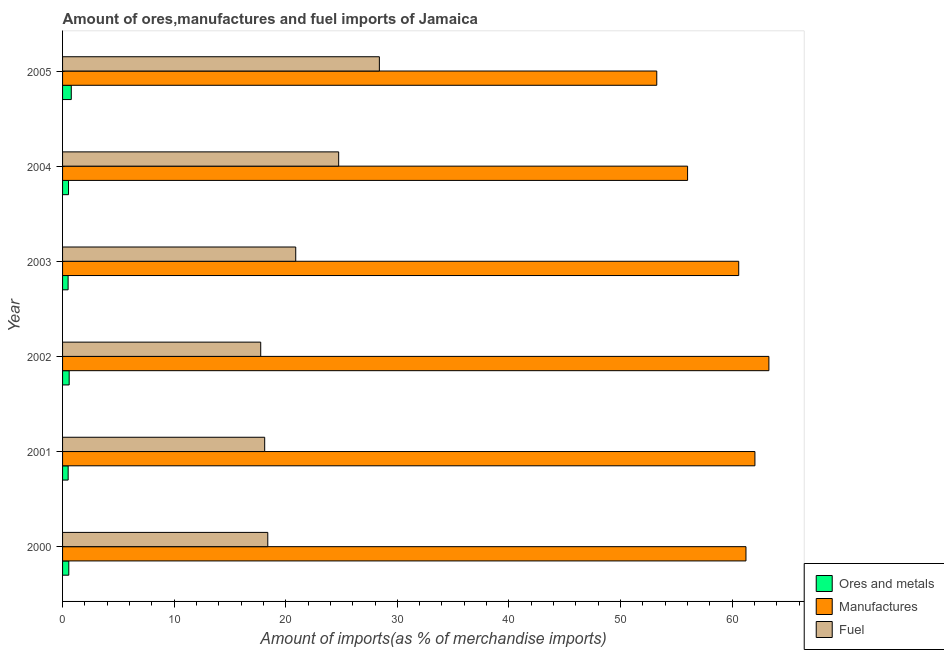How many different coloured bars are there?
Offer a terse response. 3. Are the number of bars on each tick of the Y-axis equal?
Your response must be concise. Yes. How many bars are there on the 1st tick from the bottom?
Ensure brevity in your answer.  3. What is the label of the 5th group of bars from the top?
Your answer should be very brief. 2001. What is the percentage of ores and metals imports in 2002?
Your answer should be compact. 0.59. Across all years, what is the maximum percentage of ores and metals imports?
Your answer should be very brief. 0.78. Across all years, what is the minimum percentage of fuel imports?
Offer a terse response. 17.76. What is the total percentage of manufactures imports in the graph?
Your answer should be very brief. 356.46. What is the difference between the percentage of ores and metals imports in 2001 and that in 2004?
Make the answer very short. -0.03. What is the difference between the percentage of manufactures imports in 2000 and the percentage of ores and metals imports in 2003?
Give a very brief answer. 60.75. What is the average percentage of manufactures imports per year?
Ensure brevity in your answer.  59.41. In the year 2001, what is the difference between the percentage of fuel imports and percentage of manufactures imports?
Provide a succinct answer. -43.93. In how many years, is the percentage of fuel imports greater than 18 %?
Your response must be concise. 5. What is the ratio of the percentage of fuel imports in 2004 to that in 2005?
Your answer should be compact. 0.87. Is the difference between the percentage of ores and metals imports in 2000 and 2003 greater than the difference between the percentage of manufactures imports in 2000 and 2003?
Your answer should be very brief. No. What is the difference between the highest and the second highest percentage of manufactures imports?
Offer a very short reply. 1.25. What is the difference between the highest and the lowest percentage of fuel imports?
Offer a terse response. 10.63. In how many years, is the percentage of ores and metals imports greater than the average percentage of ores and metals imports taken over all years?
Your response must be concise. 2. Is the sum of the percentage of manufactures imports in 2000 and 2001 greater than the maximum percentage of fuel imports across all years?
Make the answer very short. Yes. What does the 2nd bar from the top in 2002 represents?
Provide a short and direct response. Manufactures. What does the 3rd bar from the bottom in 2003 represents?
Give a very brief answer. Fuel. Is it the case that in every year, the sum of the percentage of ores and metals imports and percentage of manufactures imports is greater than the percentage of fuel imports?
Your answer should be compact. Yes. How many bars are there?
Make the answer very short. 18. What is the difference between two consecutive major ticks on the X-axis?
Provide a short and direct response. 10. Are the values on the major ticks of X-axis written in scientific E-notation?
Offer a very short reply. No. Where does the legend appear in the graph?
Provide a succinct answer. Bottom right. How are the legend labels stacked?
Your answer should be compact. Vertical. What is the title of the graph?
Provide a succinct answer. Amount of ores,manufactures and fuel imports of Jamaica. What is the label or title of the X-axis?
Provide a short and direct response. Amount of imports(as % of merchandise imports). What is the label or title of the Y-axis?
Make the answer very short. Year. What is the Amount of imports(as % of merchandise imports) of Ores and metals in 2000?
Ensure brevity in your answer.  0.56. What is the Amount of imports(as % of merchandise imports) in Manufactures in 2000?
Give a very brief answer. 61.25. What is the Amount of imports(as % of merchandise imports) of Fuel in 2000?
Offer a terse response. 18.39. What is the Amount of imports(as % of merchandise imports) of Ores and metals in 2001?
Provide a succinct answer. 0.5. What is the Amount of imports(as % of merchandise imports) in Manufactures in 2001?
Ensure brevity in your answer.  62.05. What is the Amount of imports(as % of merchandise imports) of Fuel in 2001?
Offer a very short reply. 18.11. What is the Amount of imports(as % of merchandise imports) of Ores and metals in 2002?
Your response must be concise. 0.59. What is the Amount of imports(as % of merchandise imports) of Manufactures in 2002?
Offer a terse response. 63.3. What is the Amount of imports(as % of merchandise imports) in Fuel in 2002?
Offer a very short reply. 17.76. What is the Amount of imports(as % of merchandise imports) of Ores and metals in 2003?
Your answer should be compact. 0.5. What is the Amount of imports(as % of merchandise imports) in Manufactures in 2003?
Your response must be concise. 60.6. What is the Amount of imports(as % of merchandise imports) of Fuel in 2003?
Give a very brief answer. 20.9. What is the Amount of imports(as % of merchandise imports) in Ores and metals in 2004?
Your answer should be compact. 0.53. What is the Amount of imports(as % of merchandise imports) in Manufactures in 2004?
Ensure brevity in your answer.  56.01. What is the Amount of imports(as % of merchandise imports) in Fuel in 2004?
Provide a succinct answer. 24.74. What is the Amount of imports(as % of merchandise imports) in Ores and metals in 2005?
Your answer should be compact. 0.78. What is the Amount of imports(as % of merchandise imports) in Manufactures in 2005?
Provide a short and direct response. 53.25. What is the Amount of imports(as % of merchandise imports) in Fuel in 2005?
Your answer should be compact. 28.39. Across all years, what is the maximum Amount of imports(as % of merchandise imports) of Ores and metals?
Your answer should be compact. 0.78. Across all years, what is the maximum Amount of imports(as % of merchandise imports) of Manufactures?
Your response must be concise. 63.3. Across all years, what is the maximum Amount of imports(as % of merchandise imports) in Fuel?
Offer a terse response. 28.39. Across all years, what is the minimum Amount of imports(as % of merchandise imports) in Ores and metals?
Your answer should be very brief. 0.5. Across all years, what is the minimum Amount of imports(as % of merchandise imports) of Manufactures?
Offer a very short reply. 53.25. Across all years, what is the minimum Amount of imports(as % of merchandise imports) of Fuel?
Your answer should be compact. 17.76. What is the total Amount of imports(as % of merchandise imports) of Ores and metals in the graph?
Offer a very short reply. 3.46. What is the total Amount of imports(as % of merchandise imports) of Manufactures in the graph?
Keep it short and to the point. 356.46. What is the total Amount of imports(as % of merchandise imports) in Fuel in the graph?
Ensure brevity in your answer.  128.3. What is the difference between the Amount of imports(as % of merchandise imports) of Ores and metals in 2000 and that in 2001?
Your answer should be very brief. 0.06. What is the difference between the Amount of imports(as % of merchandise imports) of Manufactures in 2000 and that in 2001?
Your answer should be compact. -0.8. What is the difference between the Amount of imports(as % of merchandise imports) in Fuel in 2000 and that in 2001?
Your answer should be compact. 0.28. What is the difference between the Amount of imports(as % of merchandise imports) in Ores and metals in 2000 and that in 2002?
Provide a succinct answer. -0.03. What is the difference between the Amount of imports(as % of merchandise imports) of Manufactures in 2000 and that in 2002?
Offer a very short reply. -2.05. What is the difference between the Amount of imports(as % of merchandise imports) of Fuel in 2000 and that in 2002?
Make the answer very short. 0.63. What is the difference between the Amount of imports(as % of merchandise imports) in Ores and metals in 2000 and that in 2003?
Your answer should be very brief. 0.06. What is the difference between the Amount of imports(as % of merchandise imports) in Manufactures in 2000 and that in 2003?
Give a very brief answer. 0.65. What is the difference between the Amount of imports(as % of merchandise imports) in Fuel in 2000 and that in 2003?
Offer a very short reply. -2.51. What is the difference between the Amount of imports(as % of merchandise imports) in Ores and metals in 2000 and that in 2004?
Your answer should be compact. 0.03. What is the difference between the Amount of imports(as % of merchandise imports) of Manufactures in 2000 and that in 2004?
Make the answer very short. 5.23. What is the difference between the Amount of imports(as % of merchandise imports) of Fuel in 2000 and that in 2004?
Your answer should be very brief. -6.35. What is the difference between the Amount of imports(as % of merchandise imports) of Ores and metals in 2000 and that in 2005?
Your response must be concise. -0.22. What is the difference between the Amount of imports(as % of merchandise imports) of Manufactures in 2000 and that in 2005?
Give a very brief answer. 7.99. What is the difference between the Amount of imports(as % of merchandise imports) in Fuel in 2000 and that in 2005?
Provide a short and direct response. -10. What is the difference between the Amount of imports(as % of merchandise imports) of Ores and metals in 2001 and that in 2002?
Ensure brevity in your answer.  -0.09. What is the difference between the Amount of imports(as % of merchandise imports) of Manufactures in 2001 and that in 2002?
Make the answer very short. -1.25. What is the difference between the Amount of imports(as % of merchandise imports) of Fuel in 2001 and that in 2002?
Provide a succinct answer. 0.36. What is the difference between the Amount of imports(as % of merchandise imports) in Ores and metals in 2001 and that in 2003?
Your response must be concise. 0. What is the difference between the Amount of imports(as % of merchandise imports) of Manufactures in 2001 and that in 2003?
Your response must be concise. 1.45. What is the difference between the Amount of imports(as % of merchandise imports) in Fuel in 2001 and that in 2003?
Keep it short and to the point. -2.78. What is the difference between the Amount of imports(as % of merchandise imports) in Ores and metals in 2001 and that in 2004?
Provide a succinct answer. -0.03. What is the difference between the Amount of imports(as % of merchandise imports) in Manufactures in 2001 and that in 2004?
Your response must be concise. 6.03. What is the difference between the Amount of imports(as % of merchandise imports) of Fuel in 2001 and that in 2004?
Give a very brief answer. -6.63. What is the difference between the Amount of imports(as % of merchandise imports) in Ores and metals in 2001 and that in 2005?
Provide a short and direct response. -0.28. What is the difference between the Amount of imports(as % of merchandise imports) in Manufactures in 2001 and that in 2005?
Provide a short and direct response. 8.8. What is the difference between the Amount of imports(as % of merchandise imports) in Fuel in 2001 and that in 2005?
Provide a short and direct response. -10.28. What is the difference between the Amount of imports(as % of merchandise imports) in Ores and metals in 2002 and that in 2003?
Ensure brevity in your answer.  0.1. What is the difference between the Amount of imports(as % of merchandise imports) of Manufactures in 2002 and that in 2003?
Provide a short and direct response. 2.7. What is the difference between the Amount of imports(as % of merchandise imports) of Fuel in 2002 and that in 2003?
Your answer should be compact. -3.14. What is the difference between the Amount of imports(as % of merchandise imports) of Ores and metals in 2002 and that in 2004?
Provide a succinct answer. 0.06. What is the difference between the Amount of imports(as % of merchandise imports) of Manufactures in 2002 and that in 2004?
Offer a terse response. 7.29. What is the difference between the Amount of imports(as % of merchandise imports) of Fuel in 2002 and that in 2004?
Give a very brief answer. -6.99. What is the difference between the Amount of imports(as % of merchandise imports) in Ores and metals in 2002 and that in 2005?
Your answer should be compact. -0.19. What is the difference between the Amount of imports(as % of merchandise imports) in Manufactures in 2002 and that in 2005?
Your answer should be very brief. 10.05. What is the difference between the Amount of imports(as % of merchandise imports) of Fuel in 2002 and that in 2005?
Ensure brevity in your answer.  -10.63. What is the difference between the Amount of imports(as % of merchandise imports) in Ores and metals in 2003 and that in 2004?
Provide a succinct answer. -0.04. What is the difference between the Amount of imports(as % of merchandise imports) in Manufactures in 2003 and that in 2004?
Make the answer very short. 4.58. What is the difference between the Amount of imports(as % of merchandise imports) in Fuel in 2003 and that in 2004?
Keep it short and to the point. -3.85. What is the difference between the Amount of imports(as % of merchandise imports) in Ores and metals in 2003 and that in 2005?
Your answer should be compact. -0.28. What is the difference between the Amount of imports(as % of merchandise imports) in Manufactures in 2003 and that in 2005?
Ensure brevity in your answer.  7.34. What is the difference between the Amount of imports(as % of merchandise imports) of Fuel in 2003 and that in 2005?
Provide a short and direct response. -7.5. What is the difference between the Amount of imports(as % of merchandise imports) of Ores and metals in 2004 and that in 2005?
Offer a terse response. -0.25. What is the difference between the Amount of imports(as % of merchandise imports) of Manufactures in 2004 and that in 2005?
Ensure brevity in your answer.  2.76. What is the difference between the Amount of imports(as % of merchandise imports) in Fuel in 2004 and that in 2005?
Provide a succinct answer. -3.65. What is the difference between the Amount of imports(as % of merchandise imports) of Ores and metals in 2000 and the Amount of imports(as % of merchandise imports) of Manufactures in 2001?
Ensure brevity in your answer.  -61.49. What is the difference between the Amount of imports(as % of merchandise imports) of Ores and metals in 2000 and the Amount of imports(as % of merchandise imports) of Fuel in 2001?
Provide a succinct answer. -17.56. What is the difference between the Amount of imports(as % of merchandise imports) in Manufactures in 2000 and the Amount of imports(as % of merchandise imports) in Fuel in 2001?
Offer a terse response. 43.13. What is the difference between the Amount of imports(as % of merchandise imports) of Ores and metals in 2000 and the Amount of imports(as % of merchandise imports) of Manufactures in 2002?
Keep it short and to the point. -62.74. What is the difference between the Amount of imports(as % of merchandise imports) in Ores and metals in 2000 and the Amount of imports(as % of merchandise imports) in Fuel in 2002?
Your answer should be compact. -17.2. What is the difference between the Amount of imports(as % of merchandise imports) in Manufactures in 2000 and the Amount of imports(as % of merchandise imports) in Fuel in 2002?
Offer a very short reply. 43.49. What is the difference between the Amount of imports(as % of merchandise imports) in Ores and metals in 2000 and the Amount of imports(as % of merchandise imports) in Manufactures in 2003?
Give a very brief answer. -60.04. What is the difference between the Amount of imports(as % of merchandise imports) of Ores and metals in 2000 and the Amount of imports(as % of merchandise imports) of Fuel in 2003?
Provide a succinct answer. -20.34. What is the difference between the Amount of imports(as % of merchandise imports) of Manufactures in 2000 and the Amount of imports(as % of merchandise imports) of Fuel in 2003?
Keep it short and to the point. 40.35. What is the difference between the Amount of imports(as % of merchandise imports) in Ores and metals in 2000 and the Amount of imports(as % of merchandise imports) in Manufactures in 2004?
Provide a succinct answer. -55.46. What is the difference between the Amount of imports(as % of merchandise imports) in Ores and metals in 2000 and the Amount of imports(as % of merchandise imports) in Fuel in 2004?
Provide a short and direct response. -24.19. What is the difference between the Amount of imports(as % of merchandise imports) in Manufactures in 2000 and the Amount of imports(as % of merchandise imports) in Fuel in 2004?
Provide a short and direct response. 36.5. What is the difference between the Amount of imports(as % of merchandise imports) in Ores and metals in 2000 and the Amount of imports(as % of merchandise imports) in Manufactures in 2005?
Ensure brevity in your answer.  -52.69. What is the difference between the Amount of imports(as % of merchandise imports) in Ores and metals in 2000 and the Amount of imports(as % of merchandise imports) in Fuel in 2005?
Make the answer very short. -27.83. What is the difference between the Amount of imports(as % of merchandise imports) in Manufactures in 2000 and the Amount of imports(as % of merchandise imports) in Fuel in 2005?
Your answer should be compact. 32.85. What is the difference between the Amount of imports(as % of merchandise imports) in Ores and metals in 2001 and the Amount of imports(as % of merchandise imports) in Manufactures in 2002?
Your response must be concise. -62.8. What is the difference between the Amount of imports(as % of merchandise imports) of Ores and metals in 2001 and the Amount of imports(as % of merchandise imports) of Fuel in 2002?
Offer a very short reply. -17.26. What is the difference between the Amount of imports(as % of merchandise imports) in Manufactures in 2001 and the Amount of imports(as % of merchandise imports) in Fuel in 2002?
Give a very brief answer. 44.29. What is the difference between the Amount of imports(as % of merchandise imports) of Ores and metals in 2001 and the Amount of imports(as % of merchandise imports) of Manufactures in 2003?
Give a very brief answer. -60.09. What is the difference between the Amount of imports(as % of merchandise imports) in Ores and metals in 2001 and the Amount of imports(as % of merchandise imports) in Fuel in 2003?
Make the answer very short. -20.39. What is the difference between the Amount of imports(as % of merchandise imports) of Manufactures in 2001 and the Amount of imports(as % of merchandise imports) of Fuel in 2003?
Make the answer very short. 41.15. What is the difference between the Amount of imports(as % of merchandise imports) of Ores and metals in 2001 and the Amount of imports(as % of merchandise imports) of Manufactures in 2004?
Ensure brevity in your answer.  -55.51. What is the difference between the Amount of imports(as % of merchandise imports) in Ores and metals in 2001 and the Amount of imports(as % of merchandise imports) in Fuel in 2004?
Make the answer very short. -24.24. What is the difference between the Amount of imports(as % of merchandise imports) of Manufactures in 2001 and the Amount of imports(as % of merchandise imports) of Fuel in 2004?
Offer a very short reply. 37.3. What is the difference between the Amount of imports(as % of merchandise imports) in Ores and metals in 2001 and the Amount of imports(as % of merchandise imports) in Manufactures in 2005?
Ensure brevity in your answer.  -52.75. What is the difference between the Amount of imports(as % of merchandise imports) of Ores and metals in 2001 and the Amount of imports(as % of merchandise imports) of Fuel in 2005?
Your response must be concise. -27.89. What is the difference between the Amount of imports(as % of merchandise imports) of Manufactures in 2001 and the Amount of imports(as % of merchandise imports) of Fuel in 2005?
Make the answer very short. 33.66. What is the difference between the Amount of imports(as % of merchandise imports) of Ores and metals in 2002 and the Amount of imports(as % of merchandise imports) of Manufactures in 2003?
Offer a terse response. -60. What is the difference between the Amount of imports(as % of merchandise imports) in Ores and metals in 2002 and the Amount of imports(as % of merchandise imports) in Fuel in 2003?
Provide a succinct answer. -20.3. What is the difference between the Amount of imports(as % of merchandise imports) in Manufactures in 2002 and the Amount of imports(as % of merchandise imports) in Fuel in 2003?
Give a very brief answer. 42.41. What is the difference between the Amount of imports(as % of merchandise imports) of Ores and metals in 2002 and the Amount of imports(as % of merchandise imports) of Manufactures in 2004?
Offer a terse response. -55.42. What is the difference between the Amount of imports(as % of merchandise imports) in Ores and metals in 2002 and the Amount of imports(as % of merchandise imports) in Fuel in 2004?
Provide a succinct answer. -24.15. What is the difference between the Amount of imports(as % of merchandise imports) of Manufactures in 2002 and the Amount of imports(as % of merchandise imports) of Fuel in 2004?
Offer a terse response. 38.56. What is the difference between the Amount of imports(as % of merchandise imports) of Ores and metals in 2002 and the Amount of imports(as % of merchandise imports) of Manufactures in 2005?
Keep it short and to the point. -52.66. What is the difference between the Amount of imports(as % of merchandise imports) in Ores and metals in 2002 and the Amount of imports(as % of merchandise imports) in Fuel in 2005?
Make the answer very short. -27.8. What is the difference between the Amount of imports(as % of merchandise imports) of Manufactures in 2002 and the Amount of imports(as % of merchandise imports) of Fuel in 2005?
Provide a short and direct response. 34.91. What is the difference between the Amount of imports(as % of merchandise imports) of Ores and metals in 2003 and the Amount of imports(as % of merchandise imports) of Manufactures in 2004?
Your answer should be compact. -55.52. What is the difference between the Amount of imports(as % of merchandise imports) of Ores and metals in 2003 and the Amount of imports(as % of merchandise imports) of Fuel in 2004?
Ensure brevity in your answer.  -24.25. What is the difference between the Amount of imports(as % of merchandise imports) in Manufactures in 2003 and the Amount of imports(as % of merchandise imports) in Fuel in 2004?
Provide a succinct answer. 35.85. What is the difference between the Amount of imports(as % of merchandise imports) of Ores and metals in 2003 and the Amount of imports(as % of merchandise imports) of Manufactures in 2005?
Provide a succinct answer. -52.76. What is the difference between the Amount of imports(as % of merchandise imports) in Ores and metals in 2003 and the Amount of imports(as % of merchandise imports) in Fuel in 2005?
Your answer should be very brief. -27.9. What is the difference between the Amount of imports(as % of merchandise imports) of Manufactures in 2003 and the Amount of imports(as % of merchandise imports) of Fuel in 2005?
Provide a succinct answer. 32.2. What is the difference between the Amount of imports(as % of merchandise imports) in Ores and metals in 2004 and the Amount of imports(as % of merchandise imports) in Manufactures in 2005?
Make the answer very short. -52.72. What is the difference between the Amount of imports(as % of merchandise imports) of Ores and metals in 2004 and the Amount of imports(as % of merchandise imports) of Fuel in 2005?
Provide a succinct answer. -27.86. What is the difference between the Amount of imports(as % of merchandise imports) of Manufactures in 2004 and the Amount of imports(as % of merchandise imports) of Fuel in 2005?
Your answer should be compact. 27.62. What is the average Amount of imports(as % of merchandise imports) in Ores and metals per year?
Provide a succinct answer. 0.58. What is the average Amount of imports(as % of merchandise imports) in Manufactures per year?
Your answer should be very brief. 59.41. What is the average Amount of imports(as % of merchandise imports) of Fuel per year?
Your response must be concise. 21.38. In the year 2000, what is the difference between the Amount of imports(as % of merchandise imports) in Ores and metals and Amount of imports(as % of merchandise imports) in Manufactures?
Give a very brief answer. -60.69. In the year 2000, what is the difference between the Amount of imports(as % of merchandise imports) of Ores and metals and Amount of imports(as % of merchandise imports) of Fuel?
Offer a terse response. -17.83. In the year 2000, what is the difference between the Amount of imports(as % of merchandise imports) of Manufactures and Amount of imports(as % of merchandise imports) of Fuel?
Your answer should be very brief. 42.86. In the year 2001, what is the difference between the Amount of imports(as % of merchandise imports) in Ores and metals and Amount of imports(as % of merchandise imports) in Manufactures?
Ensure brevity in your answer.  -61.55. In the year 2001, what is the difference between the Amount of imports(as % of merchandise imports) in Ores and metals and Amount of imports(as % of merchandise imports) in Fuel?
Your answer should be very brief. -17.61. In the year 2001, what is the difference between the Amount of imports(as % of merchandise imports) in Manufactures and Amount of imports(as % of merchandise imports) in Fuel?
Offer a terse response. 43.93. In the year 2002, what is the difference between the Amount of imports(as % of merchandise imports) of Ores and metals and Amount of imports(as % of merchandise imports) of Manufactures?
Offer a terse response. -62.71. In the year 2002, what is the difference between the Amount of imports(as % of merchandise imports) in Ores and metals and Amount of imports(as % of merchandise imports) in Fuel?
Your answer should be compact. -17.17. In the year 2002, what is the difference between the Amount of imports(as % of merchandise imports) of Manufactures and Amount of imports(as % of merchandise imports) of Fuel?
Provide a short and direct response. 45.54. In the year 2003, what is the difference between the Amount of imports(as % of merchandise imports) of Ores and metals and Amount of imports(as % of merchandise imports) of Manufactures?
Ensure brevity in your answer.  -60.1. In the year 2003, what is the difference between the Amount of imports(as % of merchandise imports) in Ores and metals and Amount of imports(as % of merchandise imports) in Fuel?
Give a very brief answer. -20.4. In the year 2003, what is the difference between the Amount of imports(as % of merchandise imports) in Manufactures and Amount of imports(as % of merchandise imports) in Fuel?
Provide a succinct answer. 39.7. In the year 2004, what is the difference between the Amount of imports(as % of merchandise imports) of Ores and metals and Amount of imports(as % of merchandise imports) of Manufactures?
Your response must be concise. -55.48. In the year 2004, what is the difference between the Amount of imports(as % of merchandise imports) of Ores and metals and Amount of imports(as % of merchandise imports) of Fuel?
Your response must be concise. -24.21. In the year 2004, what is the difference between the Amount of imports(as % of merchandise imports) in Manufactures and Amount of imports(as % of merchandise imports) in Fuel?
Offer a terse response. 31.27. In the year 2005, what is the difference between the Amount of imports(as % of merchandise imports) of Ores and metals and Amount of imports(as % of merchandise imports) of Manufactures?
Keep it short and to the point. -52.47. In the year 2005, what is the difference between the Amount of imports(as % of merchandise imports) of Ores and metals and Amount of imports(as % of merchandise imports) of Fuel?
Ensure brevity in your answer.  -27.61. In the year 2005, what is the difference between the Amount of imports(as % of merchandise imports) of Manufactures and Amount of imports(as % of merchandise imports) of Fuel?
Your response must be concise. 24.86. What is the ratio of the Amount of imports(as % of merchandise imports) in Ores and metals in 2000 to that in 2001?
Provide a succinct answer. 1.11. What is the ratio of the Amount of imports(as % of merchandise imports) of Manufactures in 2000 to that in 2001?
Make the answer very short. 0.99. What is the ratio of the Amount of imports(as % of merchandise imports) of Fuel in 2000 to that in 2001?
Your answer should be very brief. 1.02. What is the ratio of the Amount of imports(as % of merchandise imports) of Ores and metals in 2000 to that in 2002?
Keep it short and to the point. 0.94. What is the ratio of the Amount of imports(as % of merchandise imports) of Manufactures in 2000 to that in 2002?
Offer a terse response. 0.97. What is the ratio of the Amount of imports(as % of merchandise imports) in Fuel in 2000 to that in 2002?
Your answer should be compact. 1.04. What is the ratio of the Amount of imports(as % of merchandise imports) in Ores and metals in 2000 to that in 2003?
Keep it short and to the point. 1.12. What is the ratio of the Amount of imports(as % of merchandise imports) in Manufactures in 2000 to that in 2003?
Your answer should be very brief. 1.01. What is the ratio of the Amount of imports(as % of merchandise imports) in Fuel in 2000 to that in 2003?
Your response must be concise. 0.88. What is the ratio of the Amount of imports(as % of merchandise imports) of Ores and metals in 2000 to that in 2004?
Offer a very short reply. 1.05. What is the ratio of the Amount of imports(as % of merchandise imports) in Manufactures in 2000 to that in 2004?
Provide a succinct answer. 1.09. What is the ratio of the Amount of imports(as % of merchandise imports) in Fuel in 2000 to that in 2004?
Your answer should be compact. 0.74. What is the ratio of the Amount of imports(as % of merchandise imports) in Ores and metals in 2000 to that in 2005?
Offer a very short reply. 0.71. What is the ratio of the Amount of imports(as % of merchandise imports) in Manufactures in 2000 to that in 2005?
Ensure brevity in your answer.  1.15. What is the ratio of the Amount of imports(as % of merchandise imports) of Fuel in 2000 to that in 2005?
Your answer should be compact. 0.65. What is the ratio of the Amount of imports(as % of merchandise imports) of Ores and metals in 2001 to that in 2002?
Offer a terse response. 0.85. What is the ratio of the Amount of imports(as % of merchandise imports) of Manufactures in 2001 to that in 2002?
Give a very brief answer. 0.98. What is the ratio of the Amount of imports(as % of merchandise imports) of Fuel in 2001 to that in 2002?
Offer a very short reply. 1.02. What is the ratio of the Amount of imports(as % of merchandise imports) in Ores and metals in 2001 to that in 2003?
Your response must be concise. 1.01. What is the ratio of the Amount of imports(as % of merchandise imports) in Manufactures in 2001 to that in 2003?
Give a very brief answer. 1.02. What is the ratio of the Amount of imports(as % of merchandise imports) of Fuel in 2001 to that in 2003?
Your answer should be compact. 0.87. What is the ratio of the Amount of imports(as % of merchandise imports) of Ores and metals in 2001 to that in 2004?
Provide a succinct answer. 0.94. What is the ratio of the Amount of imports(as % of merchandise imports) of Manufactures in 2001 to that in 2004?
Ensure brevity in your answer.  1.11. What is the ratio of the Amount of imports(as % of merchandise imports) of Fuel in 2001 to that in 2004?
Offer a terse response. 0.73. What is the ratio of the Amount of imports(as % of merchandise imports) in Ores and metals in 2001 to that in 2005?
Offer a very short reply. 0.64. What is the ratio of the Amount of imports(as % of merchandise imports) of Manufactures in 2001 to that in 2005?
Give a very brief answer. 1.17. What is the ratio of the Amount of imports(as % of merchandise imports) of Fuel in 2001 to that in 2005?
Your answer should be compact. 0.64. What is the ratio of the Amount of imports(as % of merchandise imports) of Ores and metals in 2002 to that in 2003?
Make the answer very short. 1.19. What is the ratio of the Amount of imports(as % of merchandise imports) of Manufactures in 2002 to that in 2003?
Offer a very short reply. 1.04. What is the ratio of the Amount of imports(as % of merchandise imports) of Fuel in 2002 to that in 2003?
Make the answer very short. 0.85. What is the ratio of the Amount of imports(as % of merchandise imports) of Ores and metals in 2002 to that in 2004?
Ensure brevity in your answer.  1.11. What is the ratio of the Amount of imports(as % of merchandise imports) of Manufactures in 2002 to that in 2004?
Ensure brevity in your answer.  1.13. What is the ratio of the Amount of imports(as % of merchandise imports) of Fuel in 2002 to that in 2004?
Keep it short and to the point. 0.72. What is the ratio of the Amount of imports(as % of merchandise imports) in Ores and metals in 2002 to that in 2005?
Make the answer very short. 0.76. What is the ratio of the Amount of imports(as % of merchandise imports) of Manufactures in 2002 to that in 2005?
Ensure brevity in your answer.  1.19. What is the ratio of the Amount of imports(as % of merchandise imports) in Fuel in 2002 to that in 2005?
Your response must be concise. 0.63. What is the ratio of the Amount of imports(as % of merchandise imports) of Ores and metals in 2003 to that in 2004?
Give a very brief answer. 0.93. What is the ratio of the Amount of imports(as % of merchandise imports) of Manufactures in 2003 to that in 2004?
Your answer should be very brief. 1.08. What is the ratio of the Amount of imports(as % of merchandise imports) of Fuel in 2003 to that in 2004?
Keep it short and to the point. 0.84. What is the ratio of the Amount of imports(as % of merchandise imports) in Ores and metals in 2003 to that in 2005?
Your answer should be compact. 0.64. What is the ratio of the Amount of imports(as % of merchandise imports) of Manufactures in 2003 to that in 2005?
Ensure brevity in your answer.  1.14. What is the ratio of the Amount of imports(as % of merchandise imports) of Fuel in 2003 to that in 2005?
Keep it short and to the point. 0.74. What is the ratio of the Amount of imports(as % of merchandise imports) in Ores and metals in 2004 to that in 2005?
Provide a succinct answer. 0.68. What is the ratio of the Amount of imports(as % of merchandise imports) in Manufactures in 2004 to that in 2005?
Your answer should be compact. 1.05. What is the ratio of the Amount of imports(as % of merchandise imports) of Fuel in 2004 to that in 2005?
Provide a short and direct response. 0.87. What is the difference between the highest and the second highest Amount of imports(as % of merchandise imports) of Ores and metals?
Give a very brief answer. 0.19. What is the difference between the highest and the second highest Amount of imports(as % of merchandise imports) in Manufactures?
Your answer should be very brief. 1.25. What is the difference between the highest and the second highest Amount of imports(as % of merchandise imports) in Fuel?
Your answer should be compact. 3.65. What is the difference between the highest and the lowest Amount of imports(as % of merchandise imports) in Ores and metals?
Offer a very short reply. 0.28. What is the difference between the highest and the lowest Amount of imports(as % of merchandise imports) of Manufactures?
Offer a very short reply. 10.05. What is the difference between the highest and the lowest Amount of imports(as % of merchandise imports) of Fuel?
Ensure brevity in your answer.  10.63. 